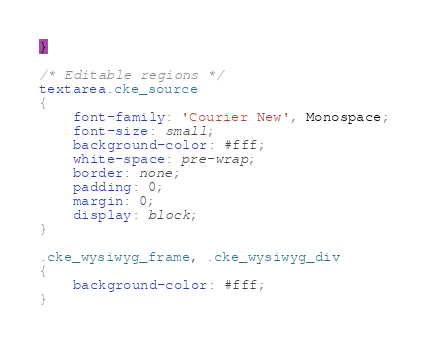<code> <loc_0><loc_0><loc_500><loc_500><_CSS_>}

/* Editable regions */
textarea.cke_source
{
	font-family: 'Courier New', Monospace;
	font-size: small;
	background-color: #fff;
	white-space: pre-wrap;
	border: none;
	padding: 0;
	margin: 0;
	display: block;
}

.cke_wysiwyg_frame, .cke_wysiwyg_div
{
	background-color: #fff;
}
</code> 